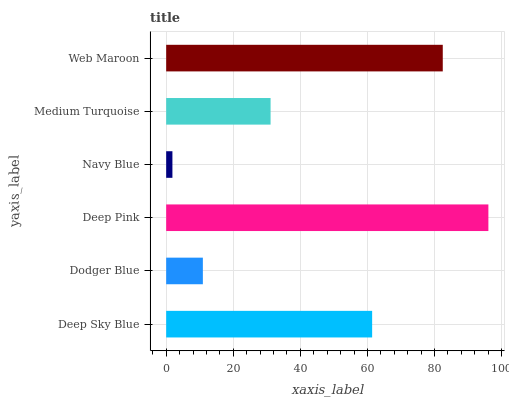Is Navy Blue the minimum?
Answer yes or no. Yes. Is Deep Pink the maximum?
Answer yes or no. Yes. Is Dodger Blue the minimum?
Answer yes or no. No. Is Dodger Blue the maximum?
Answer yes or no. No. Is Deep Sky Blue greater than Dodger Blue?
Answer yes or no. Yes. Is Dodger Blue less than Deep Sky Blue?
Answer yes or no. Yes. Is Dodger Blue greater than Deep Sky Blue?
Answer yes or no. No. Is Deep Sky Blue less than Dodger Blue?
Answer yes or no. No. Is Deep Sky Blue the high median?
Answer yes or no. Yes. Is Medium Turquoise the low median?
Answer yes or no. Yes. Is Medium Turquoise the high median?
Answer yes or no. No. Is Deep Sky Blue the low median?
Answer yes or no. No. 